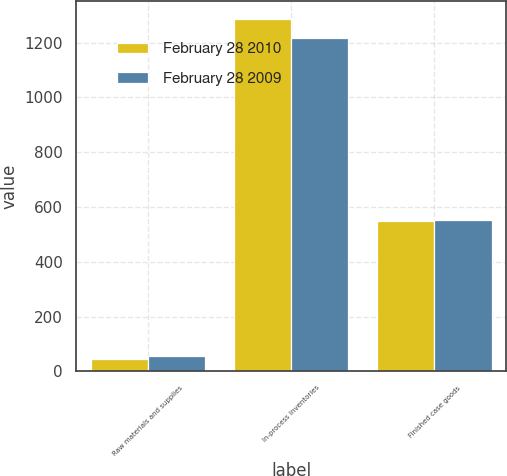Convert chart. <chart><loc_0><loc_0><loc_500><loc_500><stacked_bar_chart><ecel><fcel>Raw materials and supplies<fcel>In-process inventories<fcel>Finished case goods<nl><fcel>February 28 2010<fcel>44.3<fcel>1287<fcel>548.6<nl><fcel>February 28 2009<fcel>57.9<fcel>1218.4<fcel>552.4<nl></chart> 